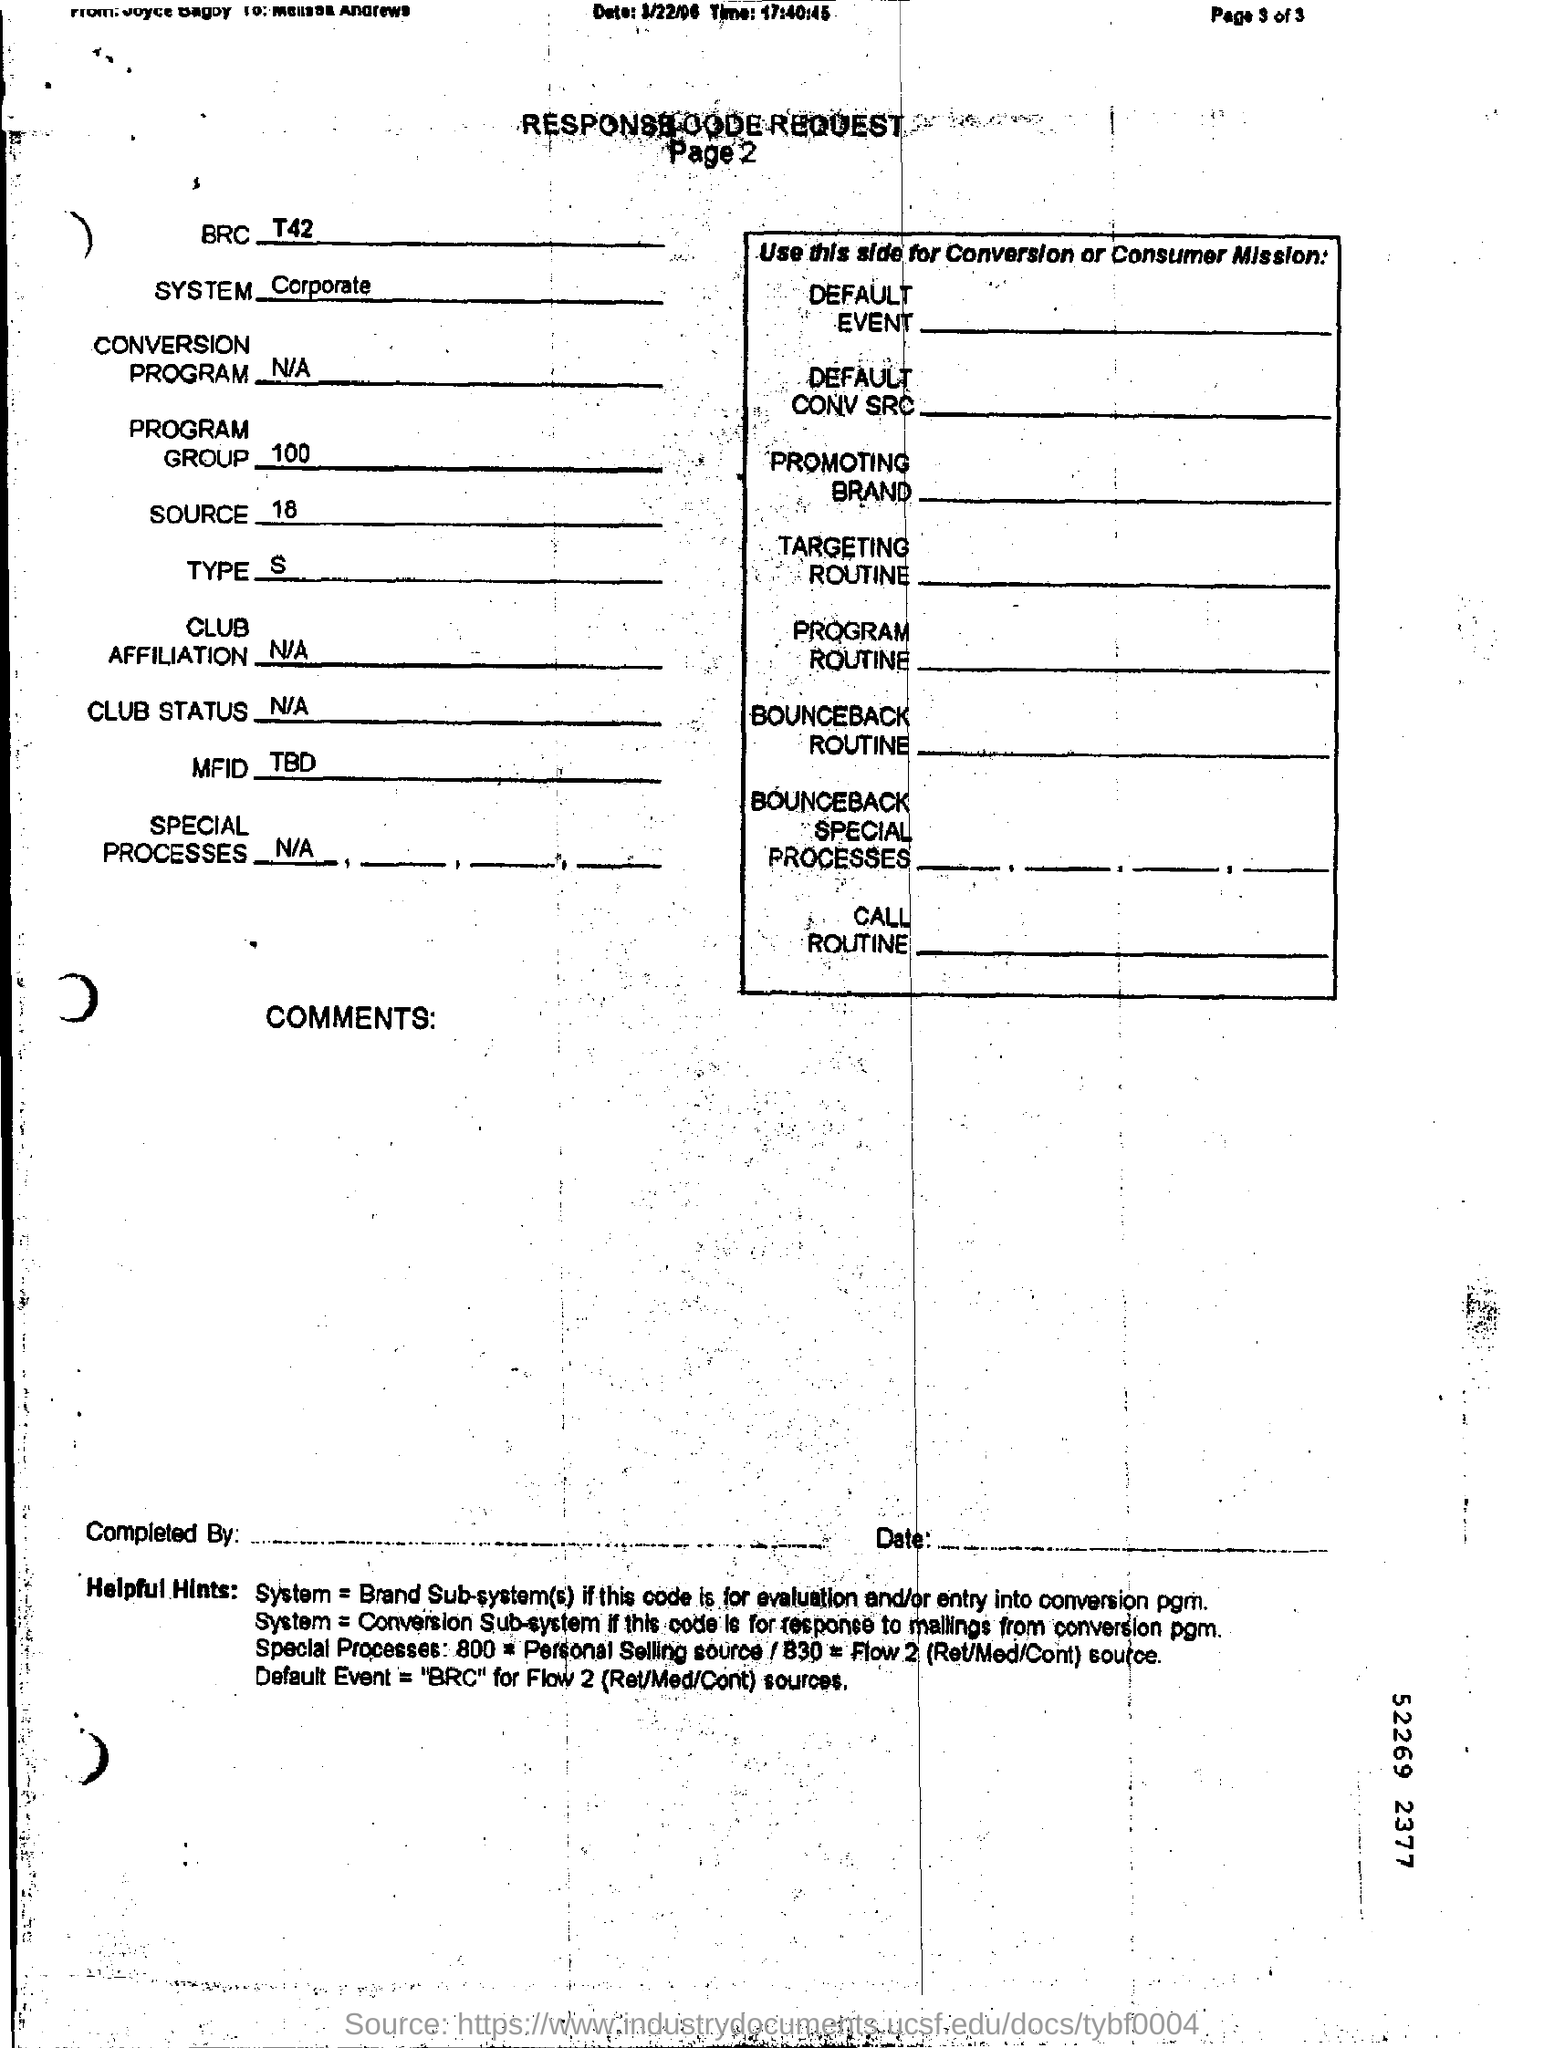What is the system?
Your response must be concise. Corporate. What is value for the program group?
Provide a succinct answer. 100. 